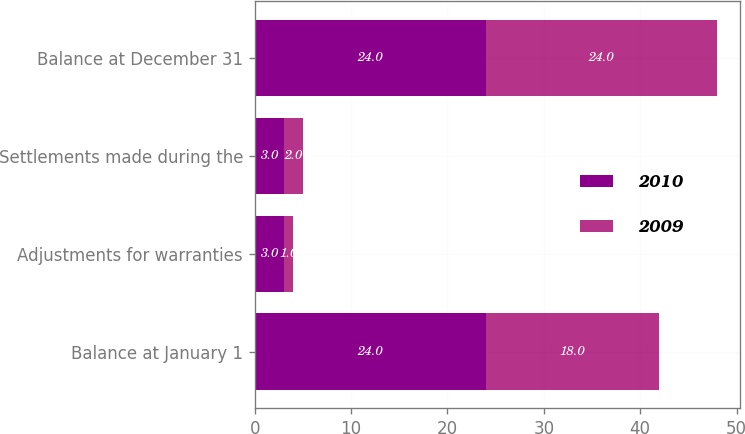Convert chart. <chart><loc_0><loc_0><loc_500><loc_500><stacked_bar_chart><ecel><fcel>Balance at January 1<fcel>Adjustments for warranties<fcel>Settlements made during the<fcel>Balance at December 31<nl><fcel>2010<fcel>24<fcel>3<fcel>3<fcel>24<nl><fcel>2009<fcel>18<fcel>1<fcel>2<fcel>24<nl></chart> 